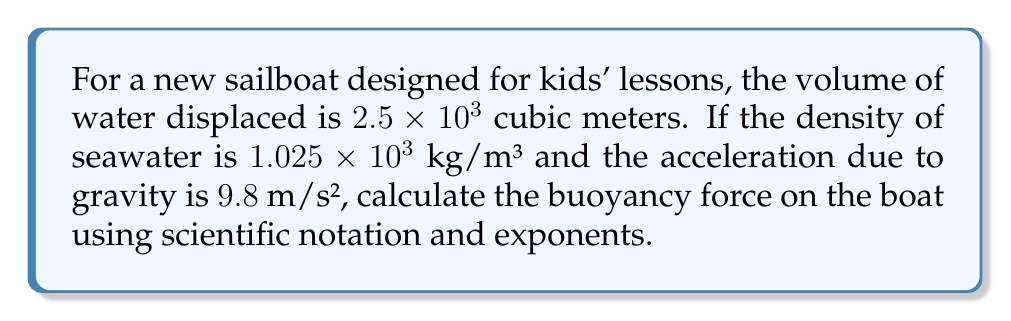Can you solve this math problem? Let's approach this step-by-step using the buoyancy force equation:

1) The buoyancy force equation is:
   $$F_b = \rho \times V \times g$$
   where $F_b$ is the buoyancy force, $\rho$ is the density of the fluid, $V$ is the volume displaced, and $g$ is the acceleration due to gravity.

2) We have:
   $\rho = 1.025 \times 10^3$ kg/m³
   $V = 2.5 \times 10^3$ m³
   $g = 9.8$ m/s²

3) Let's substitute these values into the equation:
   $$F_b = (1.025 \times 10^3) \times (2.5 \times 10^3) \times 9.8$$

4) First, let's multiply the coefficients:
   $$F_b = 1.025 \times 2.5 \times 9.8 \times 10^3 \times 10^3$$
   $$F_b = 25.1125 \times 10^6$$

5) Now, let's adjust to scientific notation:
   $$F_b = 2.51125 \times 10^7$$ N (Newtons)

6) Rounding to 3 significant figures:
   $$F_b = 2.51 \times 10^7$$ N
Answer: $2.51 \times 10^7$ N 